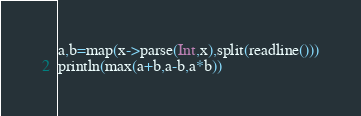<code> <loc_0><loc_0><loc_500><loc_500><_Julia_>a,b=map(x->parse(Int,x),split(readline()))
println(max(a+b,a-b,a*b))</code> 